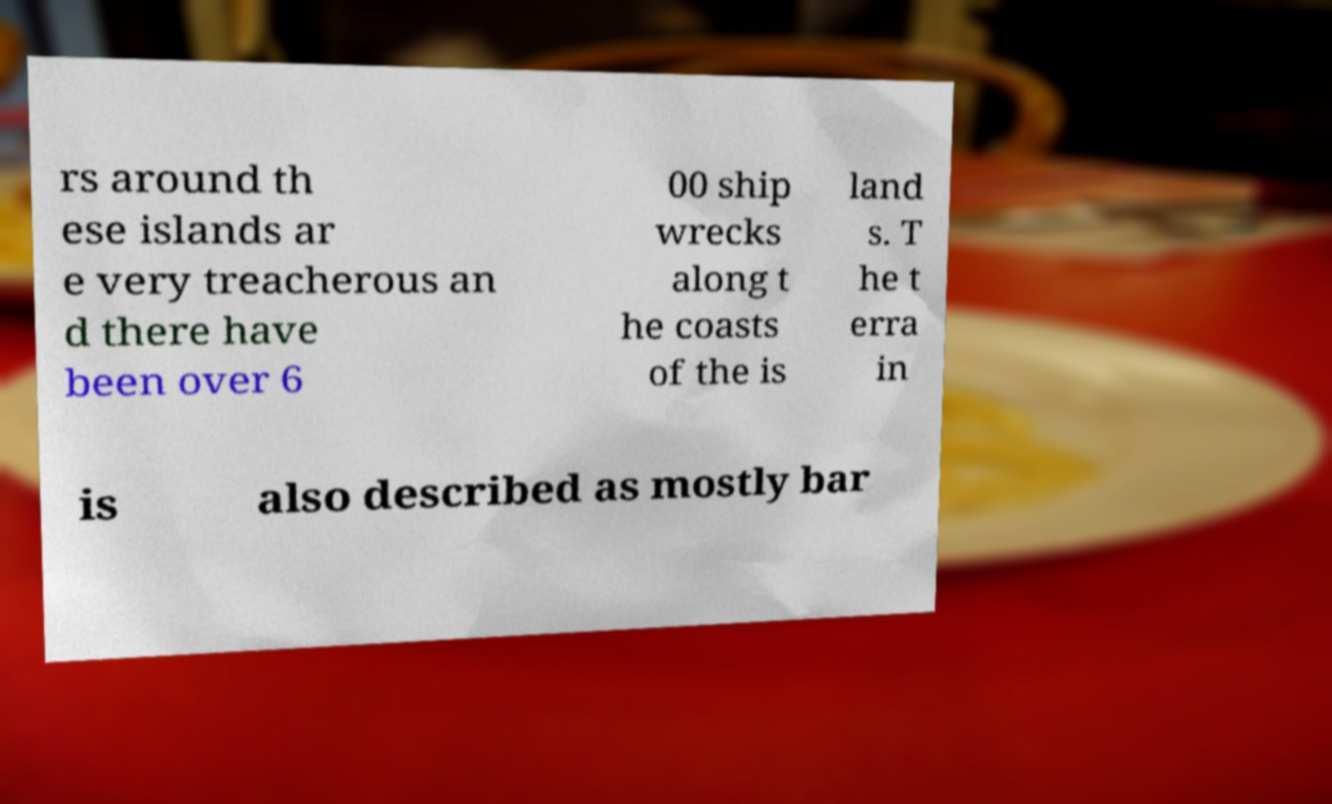Could you assist in decoding the text presented in this image and type it out clearly? rs around th ese islands ar e very treacherous an d there have been over 6 00 ship wrecks along t he coasts of the is land s. T he t erra in is also described as mostly bar 